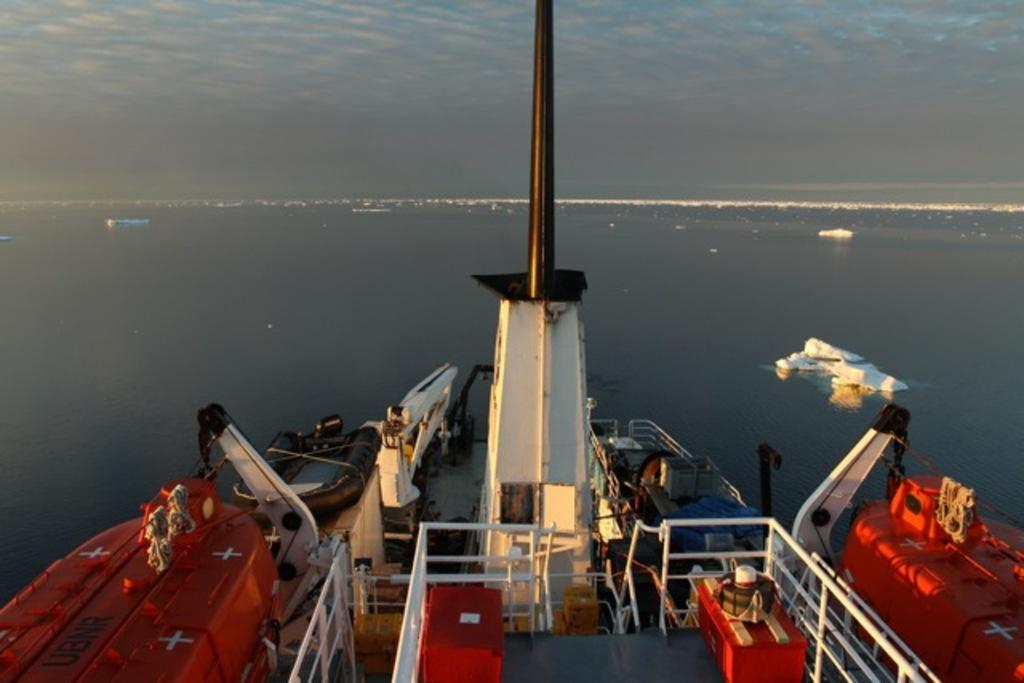What type of objects can be seen in the image? There are ropes, an inflatable boat, and objects in the ship visible in the image. What is the boat's condition in the image? The boat is inflatable. Are there any objects floating on the water in the image? Yes, there are objects floating on the water in the image. How would you describe the sky in the image? The sky is cloudy in the image. What type of discovery can be seen in the image? There is no discovery present in the image; it features ropes, an inflatable boat, objects in the ship, floating objects, and a cloudy sky. What color is the pickle floating in the water in the image? There is no pickle present in the image. 